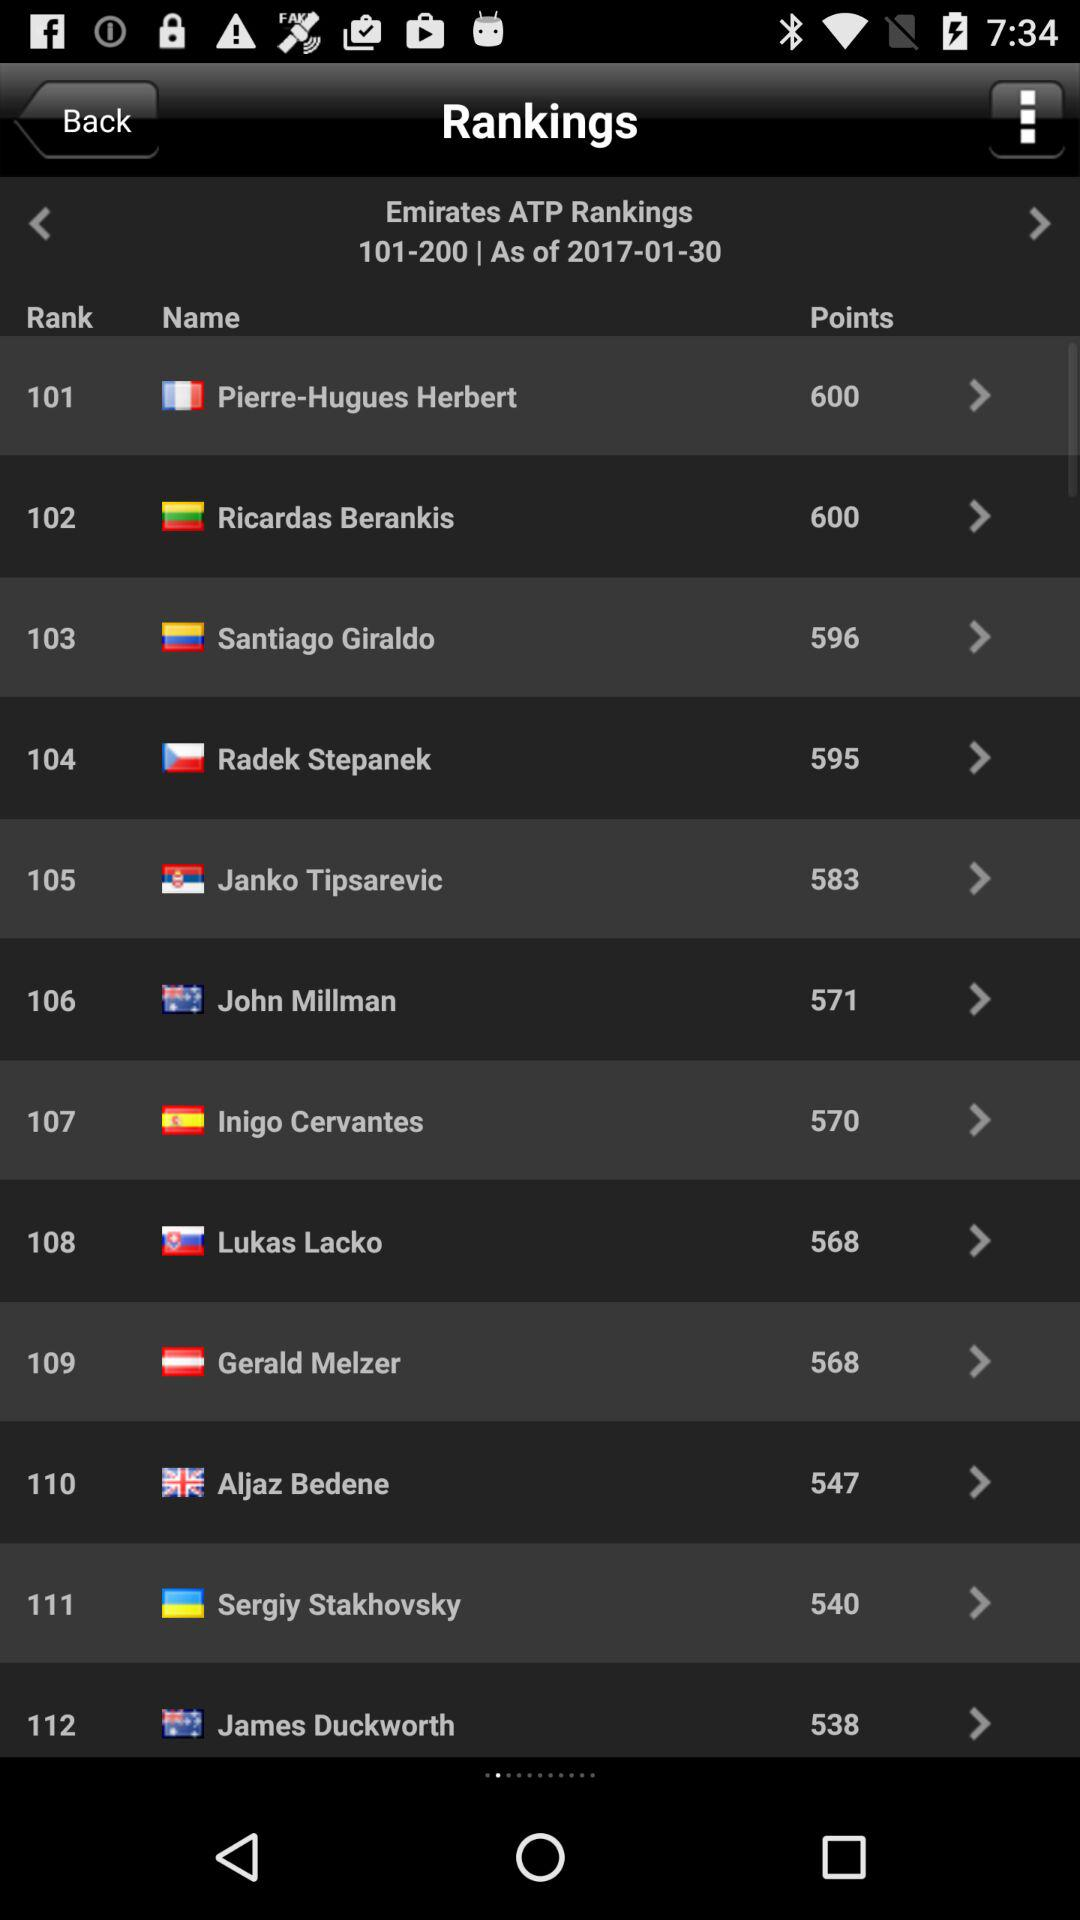What are the points of Pierre-Hugues Herbert? The points of Pierre-Hugues Herbert are 600. 